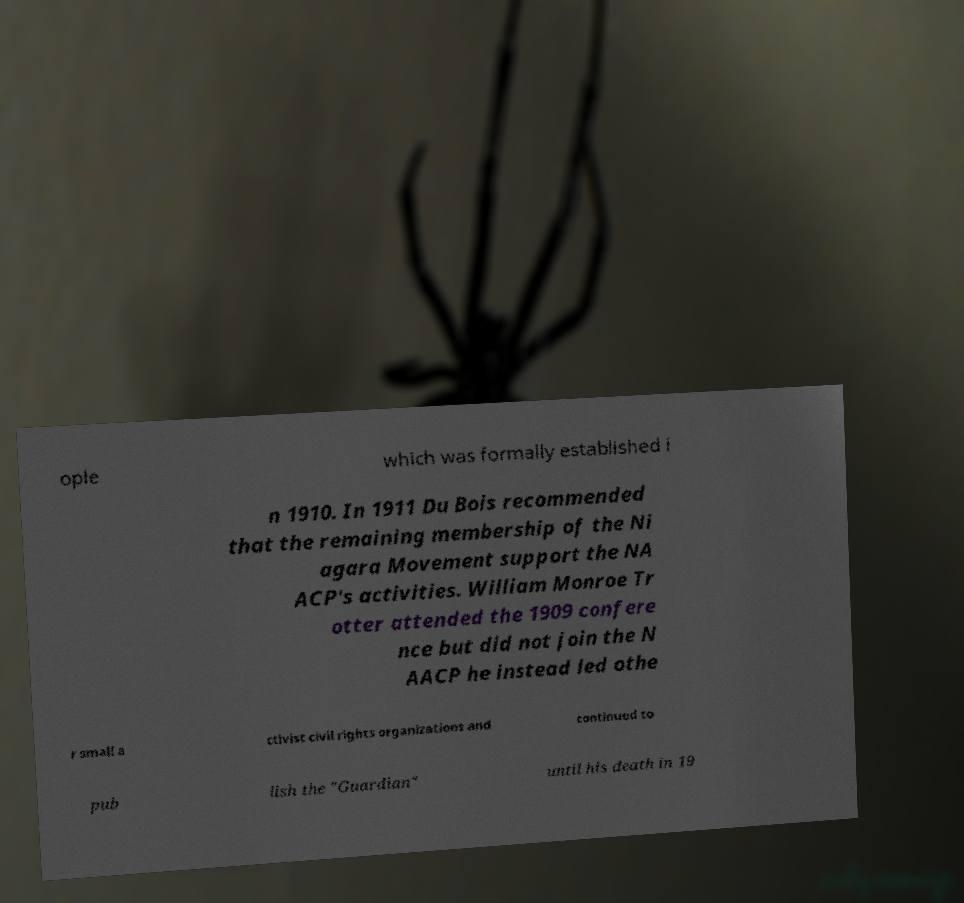Could you assist in decoding the text presented in this image and type it out clearly? ople which was formally established i n 1910. In 1911 Du Bois recommended that the remaining membership of the Ni agara Movement support the NA ACP's activities. William Monroe Tr otter attended the 1909 confere nce but did not join the N AACP he instead led othe r small a ctivist civil rights organizations and continued to pub lish the "Guardian" until his death in 19 